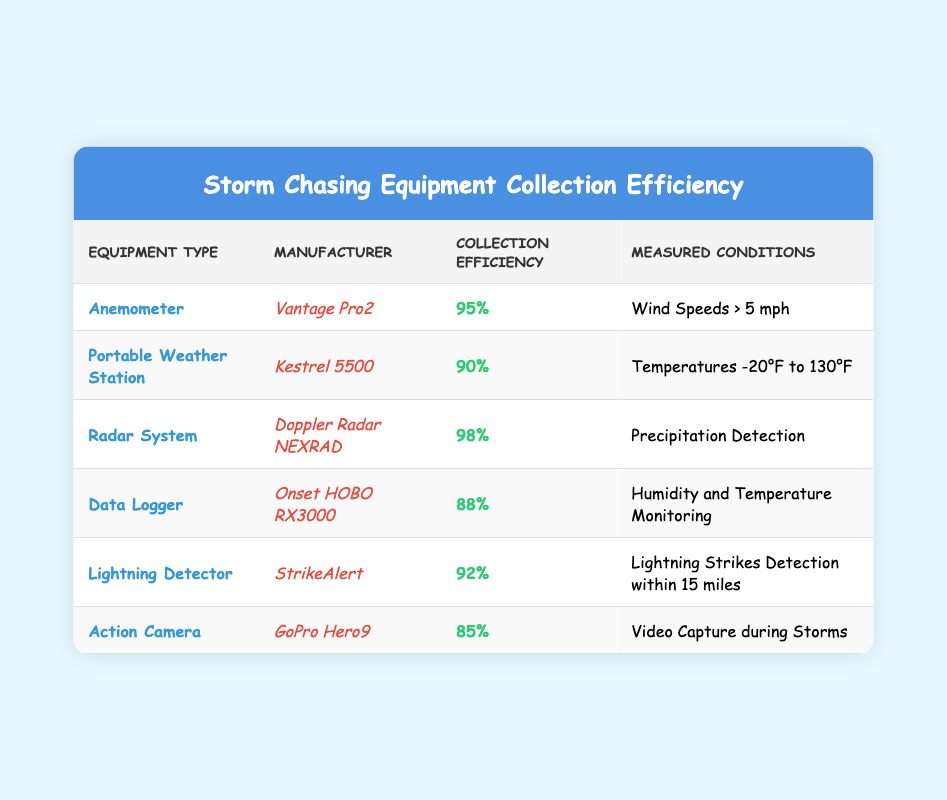What is the collection efficiency of the Radar System? The Radar System is listed in the table with its collection efficiency specified as 98%.
Answer: 98% Which equipment type has the highest collection efficiency? By comparing the collection efficiencies listed in the table, the Radar System has the highest collection efficiency at 98%.
Answer: Radar System Is the collection efficiency of the Action Camera greater than 90%? The collection efficiency of the Action Camera is 85%, which is less than 90%.
Answer: No What equipment has a collection efficiency between 90% and 95%? The equipment types with collection efficiencies that fall within this range are the Portable Weather Station (90%) and the Lightning Detector (92%).
Answer: Portable Weather Station, Lightning Detector What is the average collection efficiency of the equipment listed? To calculate the average, sum the efficiencies: (95 + 90 + 98 + 88 + 92 + 85) = 548. There are 6 pieces of equipment, so the average is 548 / 6 = 91.33%.
Answer: 91.33% Does the Data Logger have a greater collection efficiency than the Lightning Detector? The Data Logger has a collection efficiency of 88% while the Lightning Detector's efficiency is 92%, hence the Data Logger does not have a greater efficiency.
Answer: No How many equipment types have a collection efficiency below 90%? Among the listed equipment, the Action Camera and Data Logger have efficiencies of 85% and 88%, respectively, totaling two equipment types.
Answer: 2 What is the difference in collection efficiency between the Anemometer and the Action Camera? The Anemometer has a collection efficiency of 95% and the Action Camera has 85%, so the difference is 95 - 85 = 10%.
Answer: 10% 